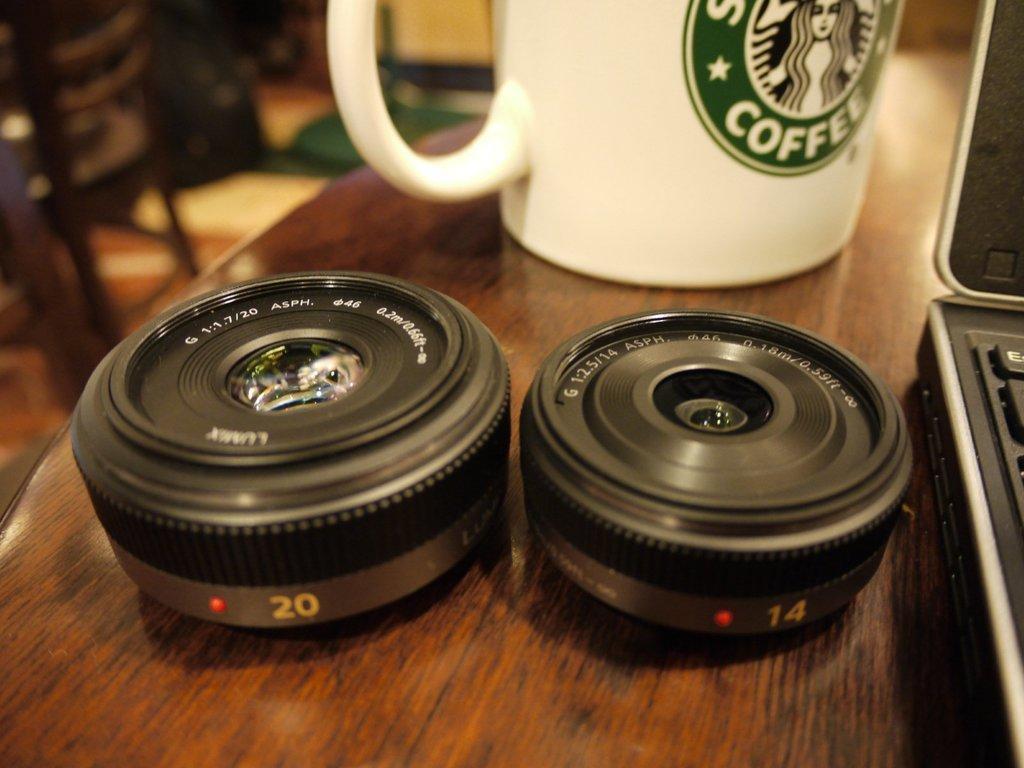Please provide a concise description of this image. In this image we can see two lens and a coffee mug is placed on a table along with a laptop. In the background we can see a chair. 